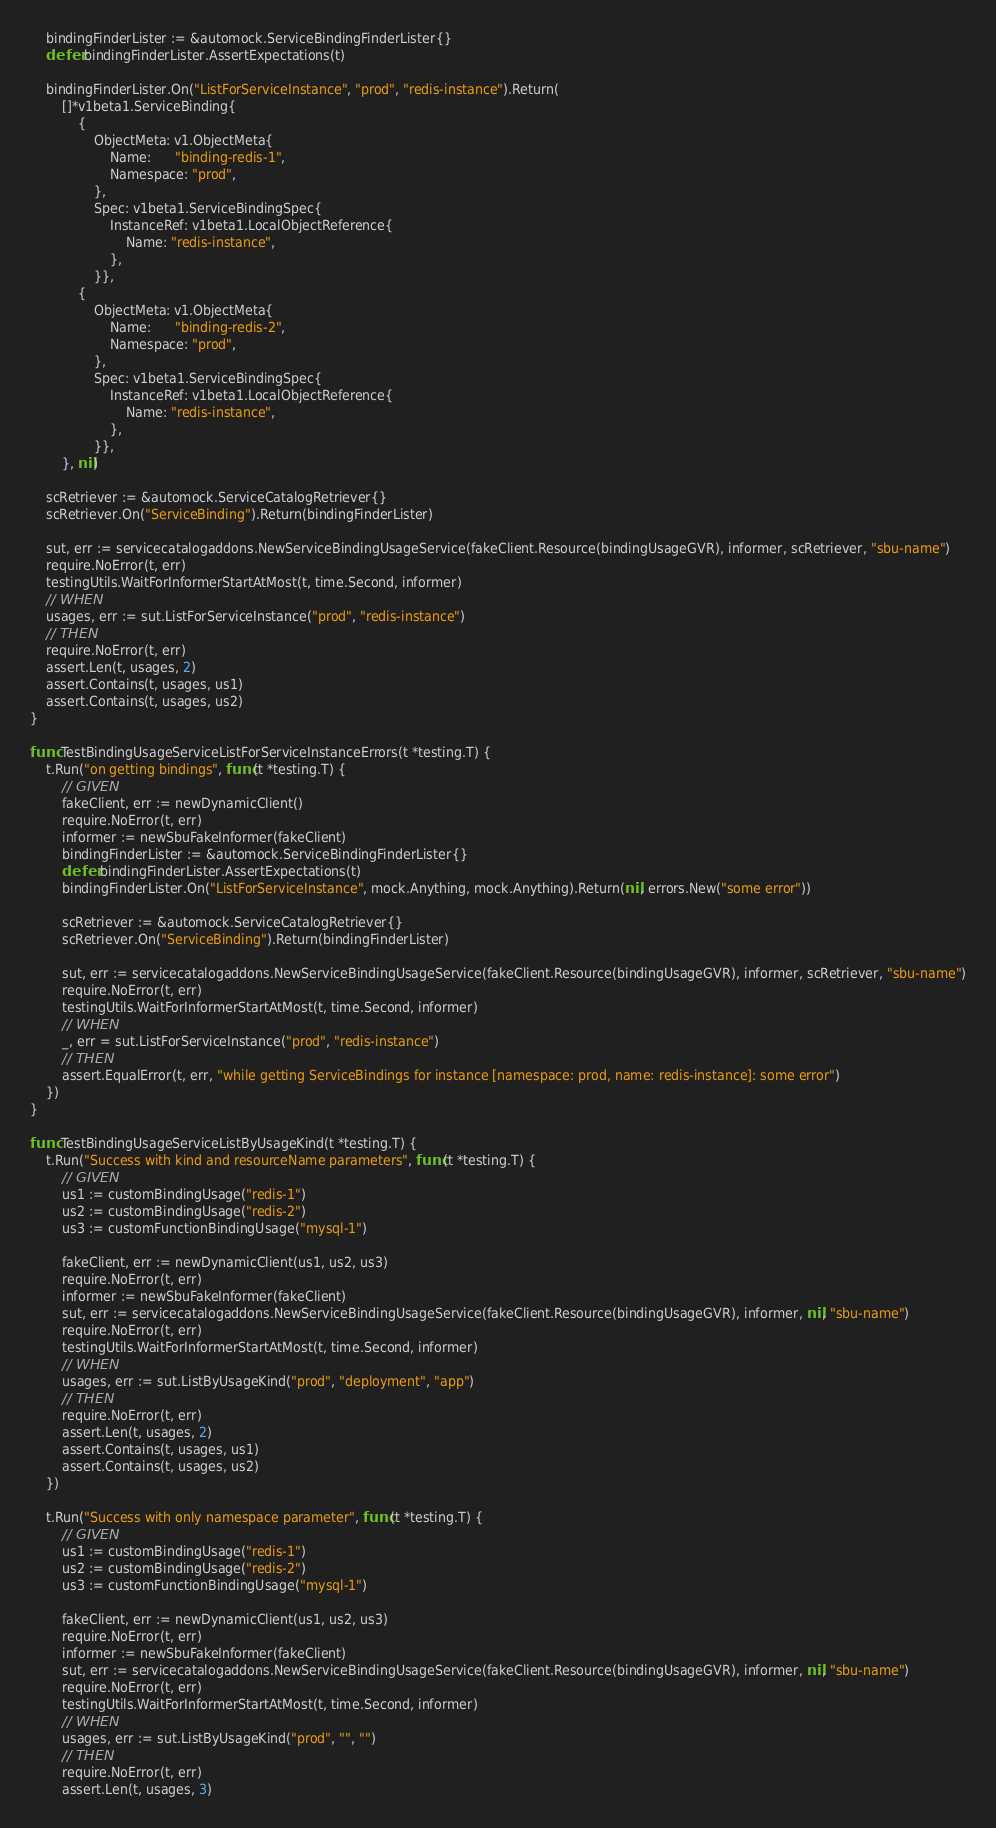Convert code to text. <code><loc_0><loc_0><loc_500><loc_500><_Go_>	bindingFinderLister := &automock.ServiceBindingFinderLister{}
	defer bindingFinderLister.AssertExpectations(t)

	bindingFinderLister.On("ListForServiceInstance", "prod", "redis-instance").Return(
		[]*v1beta1.ServiceBinding{
			{
				ObjectMeta: v1.ObjectMeta{
					Name:      "binding-redis-1",
					Namespace: "prod",
				},
				Spec: v1beta1.ServiceBindingSpec{
					InstanceRef: v1beta1.LocalObjectReference{
						Name: "redis-instance",
					},
				}},
			{
				ObjectMeta: v1.ObjectMeta{
					Name:      "binding-redis-2",
					Namespace: "prod",
				},
				Spec: v1beta1.ServiceBindingSpec{
					InstanceRef: v1beta1.LocalObjectReference{
						Name: "redis-instance",
					},
				}},
		}, nil)

	scRetriever := &automock.ServiceCatalogRetriever{}
	scRetriever.On("ServiceBinding").Return(bindingFinderLister)

	sut, err := servicecatalogaddons.NewServiceBindingUsageService(fakeClient.Resource(bindingUsageGVR), informer, scRetriever, "sbu-name")
	require.NoError(t, err)
	testingUtils.WaitForInformerStartAtMost(t, time.Second, informer)
	// WHEN
	usages, err := sut.ListForServiceInstance("prod", "redis-instance")
	// THEN
	require.NoError(t, err)
	assert.Len(t, usages, 2)
	assert.Contains(t, usages, us1)
	assert.Contains(t, usages, us2)
}

func TestBindingUsageServiceListForServiceInstanceErrors(t *testing.T) {
	t.Run("on getting bindings", func(t *testing.T) {
		// GIVEN
		fakeClient, err := newDynamicClient()
		require.NoError(t, err)
		informer := newSbuFakeInformer(fakeClient)
		bindingFinderLister := &automock.ServiceBindingFinderLister{}
		defer bindingFinderLister.AssertExpectations(t)
		bindingFinderLister.On("ListForServiceInstance", mock.Anything, mock.Anything).Return(nil, errors.New("some error"))

		scRetriever := &automock.ServiceCatalogRetriever{}
		scRetriever.On("ServiceBinding").Return(bindingFinderLister)

		sut, err := servicecatalogaddons.NewServiceBindingUsageService(fakeClient.Resource(bindingUsageGVR), informer, scRetriever, "sbu-name")
		require.NoError(t, err)
		testingUtils.WaitForInformerStartAtMost(t, time.Second, informer)
		// WHEN
		_, err = sut.ListForServiceInstance("prod", "redis-instance")
		// THEN
		assert.EqualError(t, err, "while getting ServiceBindings for instance [namespace: prod, name: redis-instance]: some error")
	})
}

func TestBindingUsageServiceListByUsageKind(t *testing.T) {
	t.Run("Success with kind and resourceName parameters", func(t *testing.T) {
		// GIVEN
		us1 := customBindingUsage("redis-1")
		us2 := customBindingUsage("redis-2")
		us3 := customFunctionBindingUsage("mysql-1")

		fakeClient, err := newDynamicClient(us1, us2, us3)
		require.NoError(t, err)
		informer := newSbuFakeInformer(fakeClient)
		sut, err := servicecatalogaddons.NewServiceBindingUsageService(fakeClient.Resource(bindingUsageGVR), informer, nil, "sbu-name")
		require.NoError(t, err)
		testingUtils.WaitForInformerStartAtMost(t, time.Second, informer)
		// WHEN
		usages, err := sut.ListByUsageKind("prod", "deployment", "app")
		// THEN
		require.NoError(t, err)
		assert.Len(t, usages, 2)
		assert.Contains(t, usages, us1)
		assert.Contains(t, usages, us2)
	})

	t.Run("Success with only namespace parameter", func(t *testing.T) {
		// GIVEN
		us1 := customBindingUsage("redis-1")
		us2 := customBindingUsage("redis-2")
		us3 := customFunctionBindingUsage("mysql-1")

		fakeClient, err := newDynamicClient(us1, us2, us3)
		require.NoError(t, err)
		informer := newSbuFakeInformer(fakeClient)
		sut, err := servicecatalogaddons.NewServiceBindingUsageService(fakeClient.Resource(bindingUsageGVR), informer, nil, "sbu-name")
		require.NoError(t, err)
		testingUtils.WaitForInformerStartAtMost(t, time.Second, informer)
		// WHEN
		usages, err := sut.ListByUsageKind("prod", "", "")
		// THEN
		require.NoError(t, err)
		assert.Len(t, usages, 3)</code> 